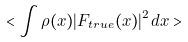<formula> <loc_0><loc_0><loc_500><loc_500>< \int \rho ( { x } ) | { F } _ { t r u e } ( { x } ) | ^ { 2 } d { x } ></formula> 